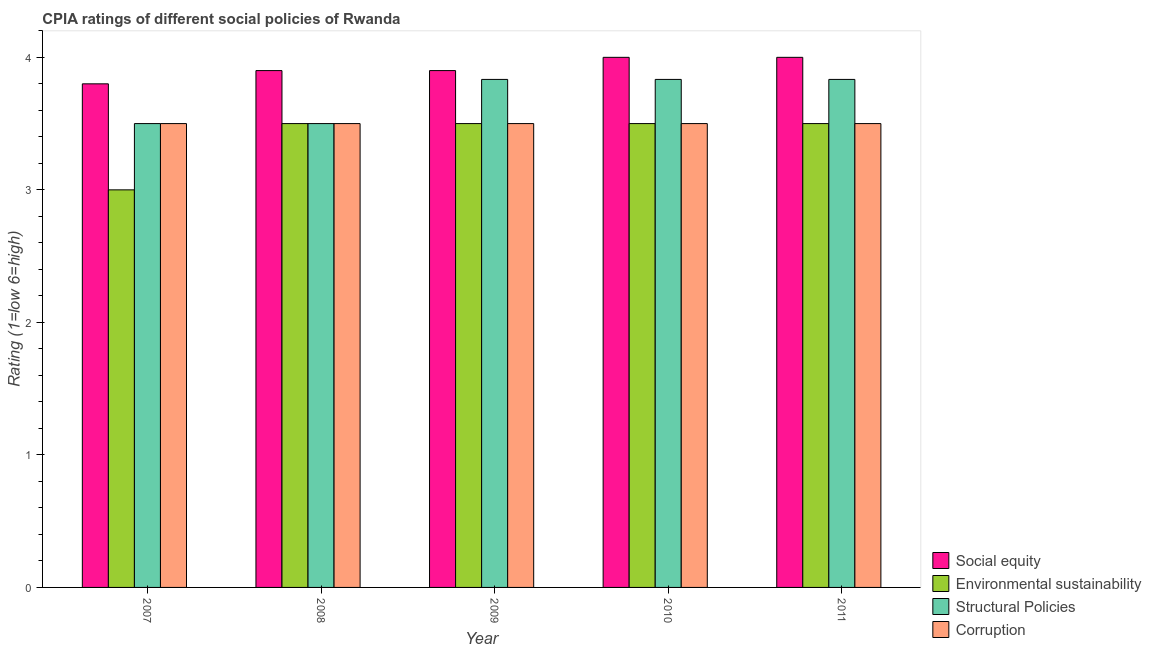Are the number of bars per tick equal to the number of legend labels?
Ensure brevity in your answer.  Yes. How many bars are there on the 4th tick from the left?
Your answer should be very brief. 4. In how many cases, is the number of bars for a given year not equal to the number of legend labels?
Make the answer very short. 0. Across all years, what is the maximum cpia rating of environmental sustainability?
Offer a terse response. 3.5. In which year was the cpia rating of environmental sustainability minimum?
Make the answer very short. 2007. What is the total cpia rating of environmental sustainability in the graph?
Offer a terse response. 17. What is the difference between the cpia rating of corruption in 2007 and that in 2010?
Provide a succinct answer. 0. What is the difference between the cpia rating of structural policies in 2009 and the cpia rating of environmental sustainability in 2007?
Provide a short and direct response. 0.33. What is the average cpia rating of environmental sustainability per year?
Give a very brief answer. 3.4. In how many years, is the cpia rating of corruption greater than 2.2?
Ensure brevity in your answer.  5. What is the ratio of the cpia rating of environmental sustainability in 2009 to that in 2011?
Offer a very short reply. 1. What is the difference between the highest and the lowest cpia rating of corruption?
Offer a very short reply. 0. Is it the case that in every year, the sum of the cpia rating of environmental sustainability and cpia rating of structural policies is greater than the sum of cpia rating of corruption and cpia rating of social equity?
Offer a terse response. No. What does the 2nd bar from the left in 2007 represents?
Make the answer very short. Environmental sustainability. What does the 1st bar from the right in 2007 represents?
Ensure brevity in your answer.  Corruption. Is it the case that in every year, the sum of the cpia rating of social equity and cpia rating of environmental sustainability is greater than the cpia rating of structural policies?
Make the answer very short. Yes. Are all the bars in the graph horizontal?
Offer a very short reply. No. What is the difference between two consecutive major ticks on the Y-axis?
Your response must be concise. 1. Are the values on the major ticks of Y-axis written in scientific E-notation?
Keep it short and to the point. No. What is the title of the graph?
Offer a very short reply. CPIA ratings of different social policies of Rwanda. What is the label or title of the Y-axis?
Your answer should be very brief. Rating (1=low 6=high). What is the Rating (1=low 6=high) of Structural Policies in 2007?
Ensure brevity in your answer.  3.5. What is the Rating (1=low 6=high) in Social equity in 2008?
Your answer should be compact. 3.9. What is the Rating (1=low 6=high) of Environmental sustainability in 2008?
Make the answer very short. 3.5. What is the Rating (1=low 6=high) in Corruption in 2008?
Offer a very short reply. 3.5. What is the Rating (1=low 6=high) in Structural Policies in 2009?
Make the answer very short. 3.83. What is the Rating (1=low 6=high) in Social equity in 2010?
Keep it short and to the point. 4. What is the Rating (1=low 6=high) in Structural Policies in 2010?
Your response must be concise. 3.83. What is the Rating (1=low 6=high) of Social equity in 2011?
Make the answer very short. 4. What is the Rating (1=low 6=high) of Environmental sustainability in 2011?
Keep it short and to the point. 3.5. What is the Rating (1=low 6=high) in Structural Policies in 2011?
Give a very brief answer. 3.83. What is the Rating (1=low 6=high) in Corruption in 2011?
Keep it short and to the point. 3.5. Across all years, what is the maximum Rating (1=low 6=high) in Structural Policies?
Your response must be concise. 3.83. Across all years, what is the minimum Rating (1=low 6=high) of Social equity?
Give a very brief answer. 3.8. Across all years, what is the minimum Rating (1=low 6=high) of Structural Policies?
Give a very brief answer. 3.5. What is the total Rating (1=low 6=high) of Social equity in the graph?
Offer a terse response. 19.6. What is the total Rating (1=low 6=high) of Structural Policies in the graph?
Your answer should be compact. 18.5. What is the total Rating (1=low 6=high) in Corruption in the graph?
Provide a short and direct response. 17.5. What is the difference between the Rating (1=low 6=high) of Social equity in 2007 and that in 2008?
Your answer should be compact. -0.1. What is the difference between the Rating (1=low 6=high) of Environmental sustainability in 2007 and that in 2008?
Make the answer very short. -0.5. What is the difference between the Rating (1=low 6=high) of Structural Policies in 2007 and that in 2008?
Provide a succinct answer. 0. What is the difference between the Rating (1=low 6=high) of Corruption in 2007 and that in 2009?
Make the answer very short. 0. What is the difference between the Rating (1=low 6=high) of Social equity in 2007 and that in 2010?
Ensure brevity in your answer.  -0.2. What is the difference between the Rating (1=low 6=high) in Structural Policies in 2007 and that in 2010?
Your response must be concise. -0.33. What is the difference between the Rating (1=low 6=high) of Corruption in 2007 and that in 2010?
Ensure brevity in your answer.  0. What is the difference between the Rating (1=low 6=high) in Social equity in 2007 and that in 2011?
Your answer should be compact. -0.2. What is the difference between the Rating (1=low 6=high) in Environmental sustainability in 2007 and that in 2011?
Your response must be concise. -0.5. What is the difference between the Rating (1=low 6=high) of Structural Policies in 2007 and that in 2011?
Offer a very short reply. -0.33. What is the difference between the Rating (1=low 6=high) of Corruption in 2007 and that in 2011?
Offer a terse response. 0. What is the difference between the Rating (1=low 6=high) in Structural Policies in 2008 and that in 2009?
Provide a short and direct response. -0.33. What is the difference between the Rating (1=low 6=high) in Environmental sustainability in 2008 and that in 2010?
Ensure brevity in your answer.  0. What is the difference between the Rating (1=low 6=high) of Structural Policies in 2008 and that in 2010?
Give a very brief answer. -0.33. What is the difference between the Rating (1=low 6=high) of Structural Policies in 2008 and that in 2011?
Offer a terse response. -0.33. What is the difference between the Rating (1=low 6=high) in Corruption in 2008 and that in 2011?
Your answer should be compact. 0. What is the difference between the Rating (1=low 6=high) of Environmental sustainability in 2009 and that in 2010?
Make the answer very short. 0. What is the difference between the Rating (1=low 6=high) in Corruption in 2009 and that in 2010?
Offer a very short reply. 0. What is the difference between the Rating (1=low 6=high) of Social equity in 2009 and that in 2011?
Keep it short and to the point. -0.1. What is the difference between the Rating (1=low 6=high) in Environmental sustainability in 2009 and that in 2011?
Ensure brevity in your answer.  0. What is the difference between the Rating (1=low 6=high) in Structural Policies in 2009 and that in 2011?
Provide a succinct answer. 0. What is the difference between the Rating (1=low 6=high) in Environmental sustainability in 2010 and that in 2011?
Provide a short and direct response. 0. What is the difference between the Rating (1=low 6=high) in Social equity in 2007 and the Rating (1=low 6=high) in Environmental sustainability in 2008?
Make the answer very short. 0.3. What is the difference between the Rating (1=low 6=high) of Social equity in 2007 and the Rating (1=low 6=high) of Structural Policies in 2009?
Give a very brief answer. -0.03. What is the difference between the Rating (1=low 6=high) of Environmental sustainability in 2007 and the Rating (1=low 6=high) of Structural Policies in 2009?
Ensure brevity in your answer.  -0.83. What is the difference between the Rating (1=low 6=high) of Environmental sustainability in 2007 and the Rating (1=low 6=high) of Corruption in 2009?
Your answer should be very brief. -0.5. What is the difference between the Rating (1=low 6=high) of Structural Policies in 2007 and the Rating (1=low 6=high) of Corruption in 2009?
Offer a very short reply. 0. What is the difference between the Rating (1=low 6=high) in Social equity in 2007 and the Rating (1=low 6=high) in Environmental sustainability in 2010?
Make the answer very short. 0.3. What is the difference between the Rating (1=low 6=high) in Social equity in 2007 and the Rating (1=low 6=high) in Structural Policies in 2010?
Your answer should be very brief. -0.03. What is the difference between the Rating (1=low 6=high) in Social equity in 2007 and the Rating (1=low 6=high) in Corruption in 2010?
Ensure brevity in your answer.  0.3. What is the difference between the Rating (1=low 6=high) of Social equity in 2007 and the Rating (1=low 6=high) of Environmental sustainability in 2011?
Offer a very short reply. 0.3. What is the difference between the Rating (1=low 6=high) in Social equity in 2007 and the Rating (1=low 6=high) in Structural Policies in 2011?
Your answer should be very brief. -0.03. What is the difference between the Rating (1=low 6=high) of Environmental sustainability in 2007 and the Rating (1=low 6=high) of Structural Policies in 2011?
Make the answer very short. -0.83. What is the difference between the Rating (1=low 6=high) of Social equity in 2008 and the Rating (1=low 6=high) of Structural Policies in 2009?
Your answer should be compact. 0.07. What is the difference between the Rating (1=low 6=high) in Social equity in 2008 and the Rating (1=low 6=high) in Corruption in 2009?
Ensure brevity in your answer.  0.4. What is the difference between the Rating (1=low 6=high) of Environmental sustainability in 2008 and the Rating (1=low 6=high) of Structural Policies in 2009?
Offer a very short reply. -0.33. What is the difference between the Rating (1=low 6=high) of Social equity in 2008 and the Rating (1=low 6=high) of Structural Policies in 2010?
Keep it short and to the point. 0.07. What is the difference between the Rating (1=low 6=high) of Social equity in 2008 and the Rating (1=low 6=high) of Corruption in 2010?
Make the answer very short. 0.4. What is the difference between the Rating (1=low 6=high) in Environmental sustainability in 2008 and the Rating (1=low 6=high) in Corruption in 2010?
Make the answer very short. 0. What is the difference between the Rating (1=low 6=high) of Structural Policies in 2008 and the Rating (1=low 6=high) of Corruption in 2010?
Provide a succinct answer. 0. What is the difference between the Rating (1=low 6=high) in Social equity in 2008 and the Rating (1=low 6=high) in Structural Policies in 2011?
Your answer should be compact. 0.07. What is the difference between the Rating (1=low 6=high) of Social equity in 2009 and the Rating (1=low 6=high) of Structural Policies in 2010?
Offer a terse response. 0.07. What is the difference between the Rating (1=low 6=high) in Social equity in 2009 and the Rating (1=low 6=high) in Corruption in 2010?
Make the answer very short. 0.4. What is the difference between the Rating (1=low 6=high) in Environmental sustainability in 2009 and the Rating (1=low 6=high) in Structural Policies in 2010?
Ensure brevity in your answer.  -0.33. What is the difference between the Rating (1=low 6=high) in Social equity in 2009 and the Rating (1=low 6=high) in Structural Policies in 2011?
Make the answer very short. 0.07. What is the difference between the Rating (1=low 6=high) in Social equity in 2009 and the Rating (1=low 6=high) in Corruption in 2011?
Provide a short and direct response. 0.4. What is the difference between the Rating (1=low 6=high) in Structural Policies in 2009 and the Rating (1=low 6=high) in Corruption in 2011?
Your answer should be very brief. 0.33. What is the difference between the Rating (1=low 6=high) of Social equity in 2010 and the Rating (1=low 6=high) of Corruption in 2011?
Offer a very short reply. 0.5. What is the difference between the Rating (1=low 6=high) of Environmental sustainability in 2010 and the Rating (1=low 6=high) of Structural Policies in 2011?
Your answer should be very brief. -0.33. What is the difference between the Rating (1=low 6=high) in Environmental sustainability in 2010 and the Rating (1=low 6=high) in Corruption in 2011?
Ensure brevity in your answer.  0. What is the difference between the Rating (1=low 6=high) in Structural Policies in 2010 and the Rating (1=low 6=high) in Corruption in 2011?
Your answer should be very brief. 0.33. What is the average Rating (1=low 6=high) of Social equity per year?
Provide a succinct answer. 3.92. What is the average Rating (1=low 6=high) of Environmental sustainability per year?
Ensure brevity in your answer.  3.4. In the year 2007, what is the difference between the Rating (1=low 6=high) of Social equity and Rating (1=low 6=high) of Environmental sustainability?
Offer a very short reply. 0.8. In the year 2007, what is the difference between the Rating (1=low 6=high) of Environmental sustainability and Rating (1=low 6=high) of Corruption?
Provide a short and direct response. -0.5. In the year 2008, what is the difference between the Rating (1=low 6=high) in Social equity and Rating (1=low 6=high) in Structural Policies?
Your response must be concise. 0.4. In the year 2009, what is the difference between the Rating (1=low 6=high) of Social equity and Rating (1=low 6=high) of Structural Policies?
Offer a very short reply. 0.07. In the year 2009, what is the difference between the Rating (1=low 6=high) in Social equity and Rating (1=low 6=high) in Corruption?
Provide a short and direct response. 0.4. In the year 2009, what is the difference between the Rating (1=low 6=high) of Environmental sustainability and Rating (1=low 6=high) of Structural Policies?
Your answer should be very brief. -0.33. In the year 2009, what is the difference between the Rating (1=low 6=high) in Environmental sustainability and Rating (1=low 6=high) in Corruption?
Your answer should be compact. 0. In the year 2009, what is the difference between the Rating (1=low 6=high) in Structural Policies and Rating (1=low 6=high) in Corruption?
Your answer should be compact. 0.33. In the year 2010, what is the difference between the Rating (1=low 6=high) in Social equity and Rating (1=low 6=high) in Environmental sustainability?
Provide a succinct answer. 0.5. In the year 2010, what is the difference between the Rating (1=low 6=high) in Social equity and Rating (1=low 6=high) in Structural Policies?
Offer a very short reply. 0.17. In the year 2010, what is the difference between the Rating (1=low 6=high) in Environmental sustainability and Rating (1=low 6=high) in Structural Policies?
Keep it short and to the point. -0.33. In the year 2010, what is the difference between the Rating (1=low 6=high) in Environmental sustainability and Rating (1=low 6=high) in Corruption?
Offer a very short reply. 0. In the year 2011, what is the difference between the Rating (1=low 6=high) of Social equity and Rating (1=low 6=high) of Environmental sustainability?
Ensure brevity in your answer.  0.5. In the year 2011, what is the difference between the Rating (1=low 6=high) of Structural Policies and Rating (1=low 6=high) of Corruption?
Provide a succinct answer. 0.33. What is the ratio of the Rating (1=low 6=high) of Social equity in 2007 to that in 2008?
Keep it short and to the point. 0.97. What is the ratio of the Rating (1=low 6=high) in Structural Policies in 2007 to that in 2008?
Offer a terse response. 1. What is the ratio of the Rating (1=low 6=high) of Social equity in 2007 to that in 2009?
Provide a short and direct response. 0.97. What is the ratio of the Rating (1=low 6=high) of Corruption in 2007 to that in 2009?
Ensure brevity in your answer.  1. What is the ratio of the Rating (1=low 6=high) of Social equity in 2007 to that in 2010?
Offer a very short reply. 0.95. What is the ratio of the Rating (1=low 6=high) of Environmental sustainability in 2007 to that in 2010?
Provide a short and direct response. 0.86. What is the ratio of the Rating (1=low 6=high) in Corruption in 2007 to that in 2010?
Your response must be concise. 1. What is the ratio of the Rating (1=low 6=high) of Structural Policies in 2007 to that in 2011?
Provide a short and direct response. 0.91. What is the ratio of the Rating (1=low 6=high) in Social equity in 2008 to that in 2009?
Offer a very short reply. 1. What is the ratio of the Rating (1=low 6=high) in Environmental sustainability in 2008 to that in 2009?
Provide a short and direct response. 1. What is the ratio of the Rating (1=low 6=high) in Structural Policies in 2008 to that in 2009?
Offer a terse response. 0.91. What is the ratio of the Rating (1=low 6=high) in Social equity in 2008 to that in 2010?
Your answer should be compact. 0.97. What is the ratio of the Rating (1=low 6=high) of Structural Policies in 2008 to that in 2010?
Give a very brief answer. 0.91. What is the ratio of the Rating (1=low 6=high) of Corruption in 2008 to that in 2010?
Offer a terse response. 1. What is the ratio of the Rating (1=low 6=high) in Environmental sustainability in 2008 to that in 2011?
Your answer should be very brief. 1. What is the ratio of the Rating (1=low 6=high) in Corruption in 2008 to that in 2011?
Ensure brevity in your answer.  1. What is the ratio of the Rating (1=low 6=high) of Social equity in 2009 to that in 2010?
Keep it short and to the point. 0.97. What is the ratio of the Rating (1=low 6=high) of Environmental sustainability in 2009 to that in 2010?
Ensure brevity in your answer.  1. What is the ratio of the Rating (1=low 6=high) of Social equity in 2009 to that in 2011?
Provide a short and direct response. 0.97. What is the ratio of the Rating (1=low 6=high) in Environmental sustainability in 2009 to that in 2011?
Your answer should be compact. 1. What is the ratio of the Rating (1=low 6=high) in Environmental sustainability in 2010 to that in 2011?
Your answer should be compact. 1. What is the difference between the highest and the second highest Rating (1=low 6=high) in Social equity?
Offer a very short reply. 0. What is the difference between the highest and the second highest Rating (1=low 6=high) in Environmental sustainability?
Provide a short and direct response. 0. What is the difference between the highest and the second highest Rating (1=low 6=high) in Structural Policies?
Provide a succinct answer. 0. What is the difference between the highest and the second highest Rating (1=low 6=high) of Corruption?
Give a very brief answer. 0. What is the difference between the highest and the lowest Rating (1=low 6=high) of Social equity?
Provide a succinct answer. 0.2. What is the difference between the highest and the lowest Rating (1=low 6=high) of Environmental sustainability?
Make the answer very short. 0.5. 